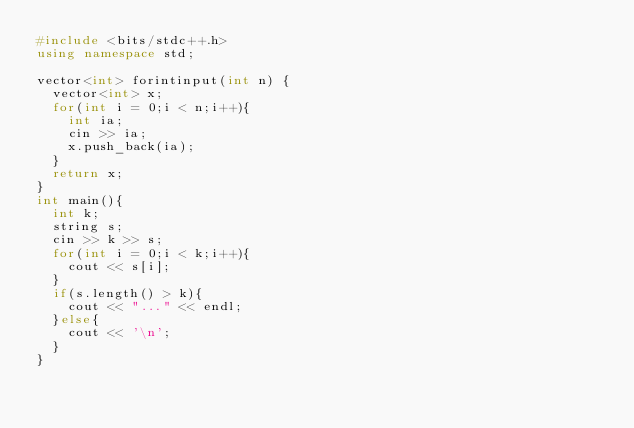<code> <loc_0><loc_0><loc_500><loc_500><_C++_>#include <bits/stdc++.h>
using namespace std;

vector<int> forintinput(int n) {
	vector<int> x;
	for(int i = 0;i < n;i++){
		int ia;
		cin >> ia;
		x.push_back(ia);
	}
	return x;
}
int main(){
	int k;
	string s;
	cin >> k >> s;
	for(int i = 0;i < k;i++){
		cout << s[i];
	}
	if(s.length() > k){
		cout << "..." << endl;
	}else{
		cout << '\n';
	}
}</code> 